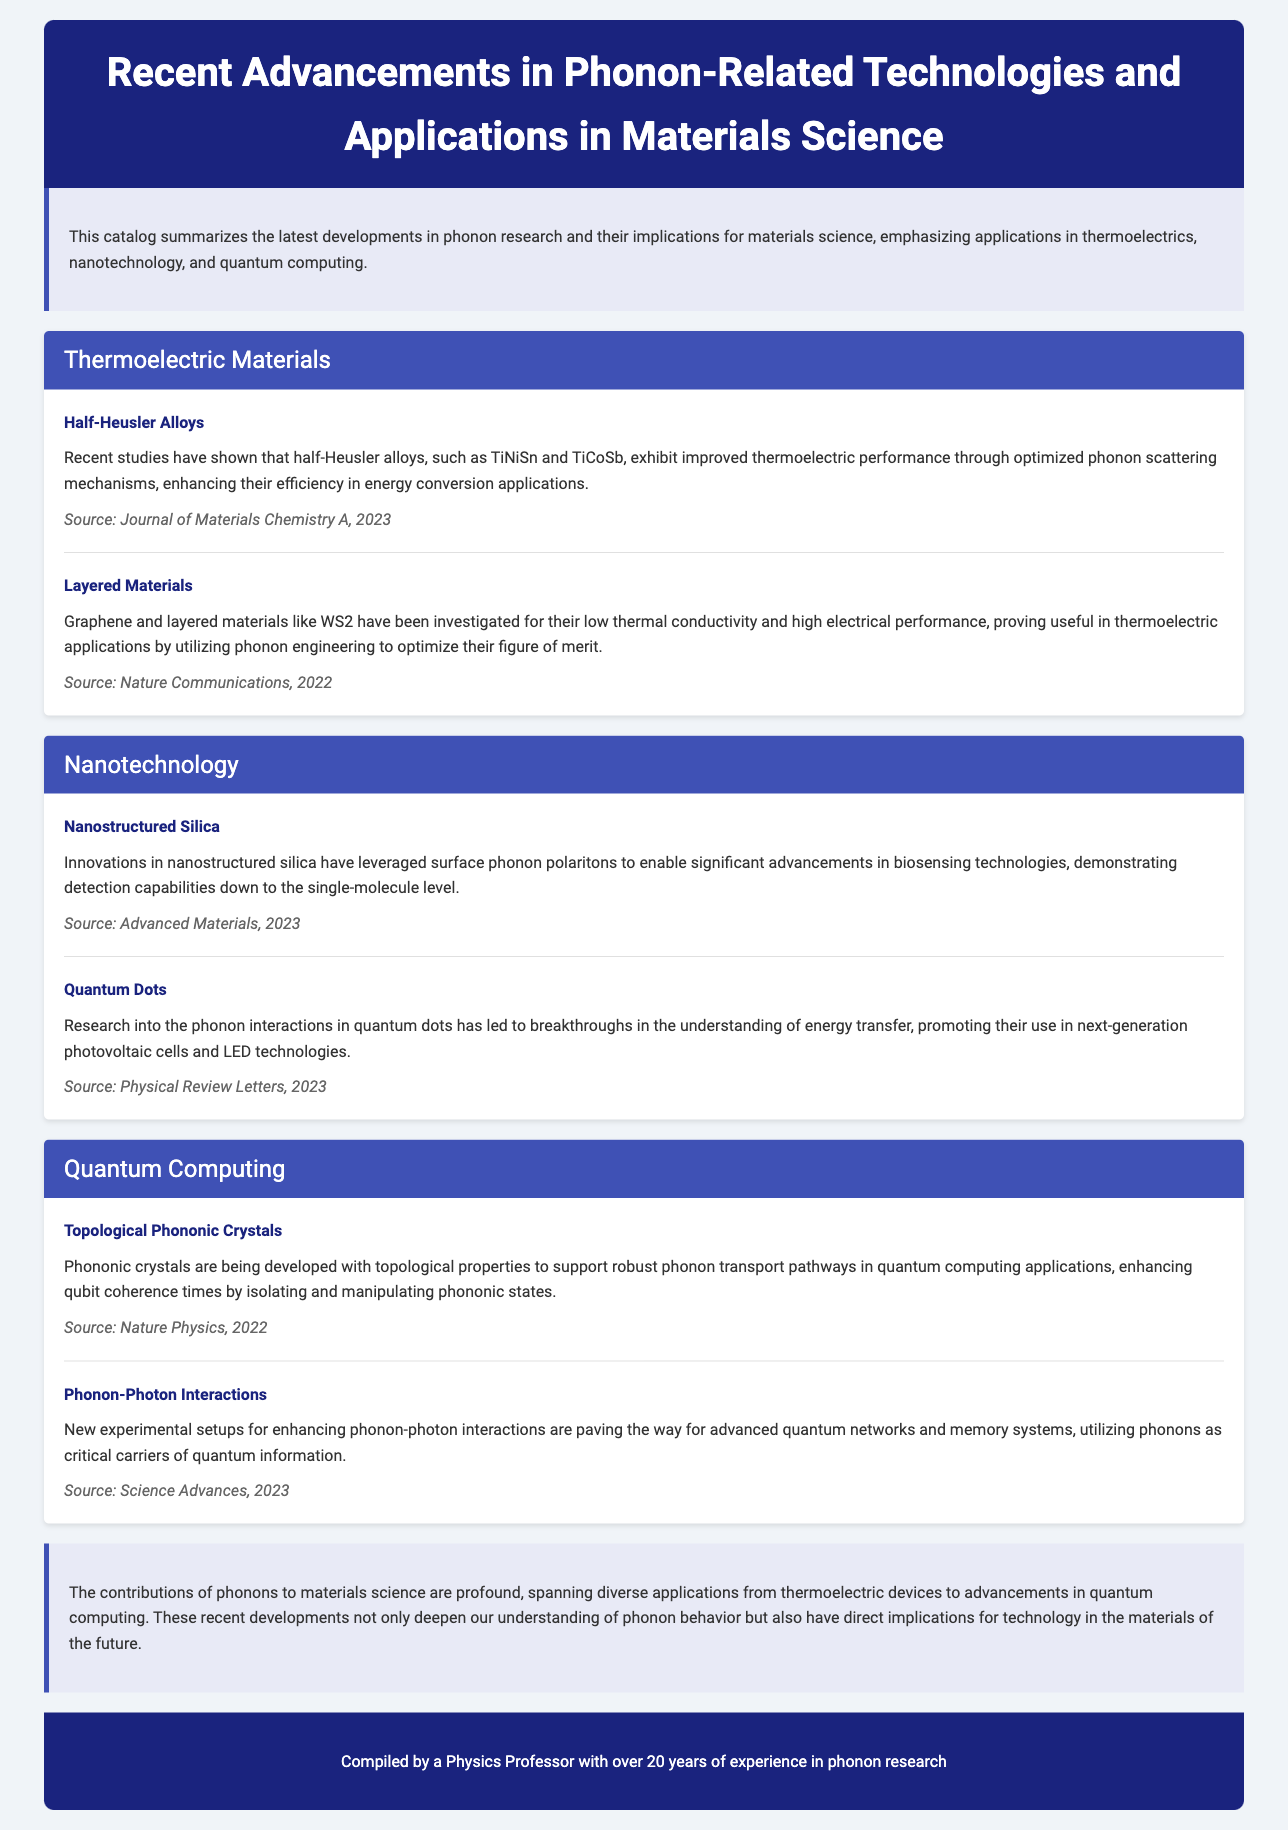What are half-Heusler alloys used for? Half-Heusler alloys are used for improved thermoelectric performance in energy conversion applications.
Answer: thermoelectric performance What is a recent application of nanostructured silica? Nanostructured silica has been used to enable significant advancements in biosensing technologies.
Answer: biosensing technologies Which materials exhibit low thermal conductivity beneficial for thermoelectric applications? Graphene and layered materials like WS2 exhibit low thermal conductivity beneficial for thermoelectric applications.
Answer: Graphene, WS2 What is the primary focus of the catalog? The catalog focuses on recent advancements in phonon research and their implications for materials science.
Answer: phonon research In which year was the source about phonon-photon interactions published? The source about phonon-photon interactions was published in 2023.
Answer: 2023 What do topological phononic crystals enhance in quantum computing applications? Topological phononic crystals enhance qubit coherence times in quantum computing applications.
Answer: qubit coherence times Which publication discusses the advancements in quantum dots? The advancements in quantum dots are discussed in Physical Review Letters.
Answer: Physical Review Letters How long has the compiled data been researched by the professor? The data has been researched by the professor for over 20 years.
Answer: over 20 years What property do phononic crystals support for robust phonon transport? Phononic crystals support topological properties for robust phonon transport pathways.
Answer: topological properties 